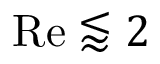Convert formula to latex. <formula><loc_0><loc_0><loc_500><loc_500>R e \lessapprox 2</formula> 